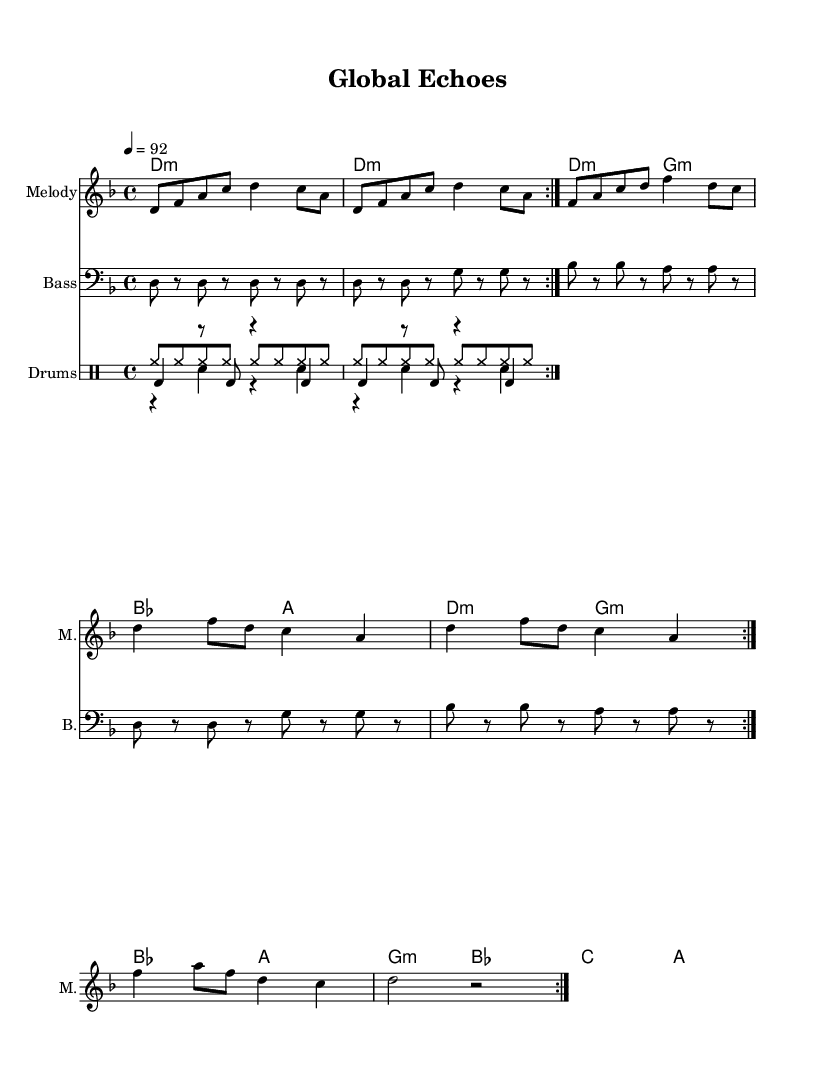What is the key signature of this music? The key signature is D minor, which has one flat (B flat). This can be identified from the key signature symbol placed at the beginning of the staff in the sheet music.
Answer: D minor What is the time signature? The time signature is 4/4, which indicates that there are four beats in each measure and a quarter note gets one beat. This can be seen at the beginning of the music, displayed as "4/4".
Answer: 4/4 What is the tempo of the piece? The tempo is 92 beats per minute, indicated by the tempo marking that specifies "4 = 92". This marking shows the speed at which the piece should be played.
Answer: 92 How many measures are repeated in the melody? The melody includes a repeat of two measures, as indicated by the "repeat volta 2" marking. This indicates that the section should be played twice.
Answer: 2 Which instrument has a bass clef in the score? The instrument with a bass clef is the "Bass", which is identified by the "Bass" label and the clef sign at the beginning of its staff. This clef is specifically designed for lower-pitched instruments.
Answer: Bass What is the primary role of the drum patterns in hip hop music? The primary role of the drum patterns in hip hop music is to provide the rhythmic foundation. The combination of the kick, snare, and hi-hat patterns creates a beat that supports the vocals and other instruments in hip hop tracks.
Answer: Rhythm 